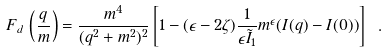<formula> <loc_0><loc_0><loc_500><loc_500>F _ { d } \, \left ( \frac { q } { m } \right ) = \frac { m ^ { 4 } } { ( q ^ { 2 } + m ^ { 2 } ) ^ { 2 } } \left [ 1 - ( \epsilon - 2 \zeta ) \frac { 1 } { \epsilon \tilde { I } _ { 1 } } m ^ { \epsilon } ( I ( q ) - I ( 0 ) ) \right ] \ .</formula> 